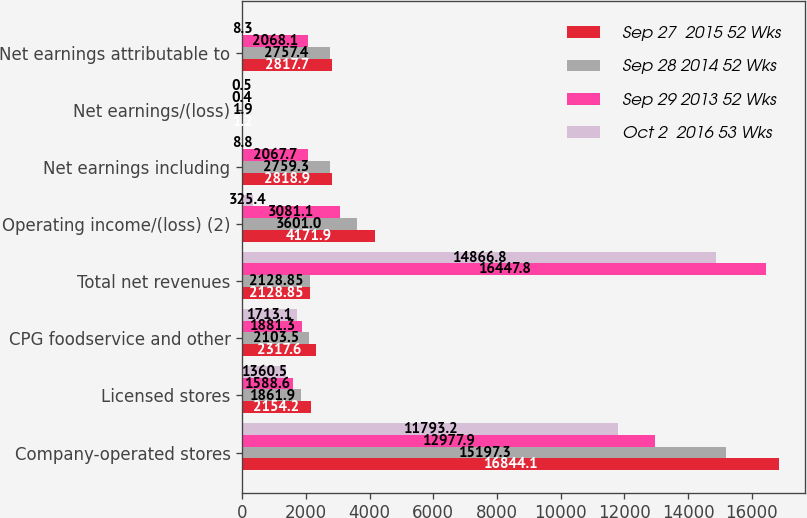Convert chart to OTSL. <chart><loc_0><loc_0><loc_500><loc_500><stacked_bar_chart><ecel><fcel>Company-operated stores<fcel>Licensed stores<fcel>CPG foodservice and other<fcel>Total net revenues<fcel>Operating income/(loss) (2)<fcel>Net earnings including<fcel>Net earnings/(loss)<fcel>Net earnings attributable to<nl><fcel>Sep 27  2015 52 Wks<fcel>16844.1<fcel>2154.2<fcel>2317.6<fcel>2128.85<fcel>4171.9<fcel>2818.9<fcel>1.2<fcel>2817.7<nl><fcel>Sep 28 2014 52 Wks<fcel>15197.3<fcel>1861.9<fcel>2103.5<fcel>2128.85<fcel>3601<fcel>2759.3<fcel>1.9<fcel>2757.4<nl><fcel>Sep 29 2013 52 Wks<fcel>12977.9<fcel>1588.6<fcel>1881.3<fcel>16447.8<fcel>3081.1<fcel>2067.7<fcel>0.4<fcel>2068.1<nl><fcel>Oct 2  2016 53 Wks<fcel>11793.2<fcel>1360.5<fcel>1713.1<fcel>14866.8<fcel>325.4<fcel>8.8<fcel>0.5<fcel>8.3<nl></chart> 